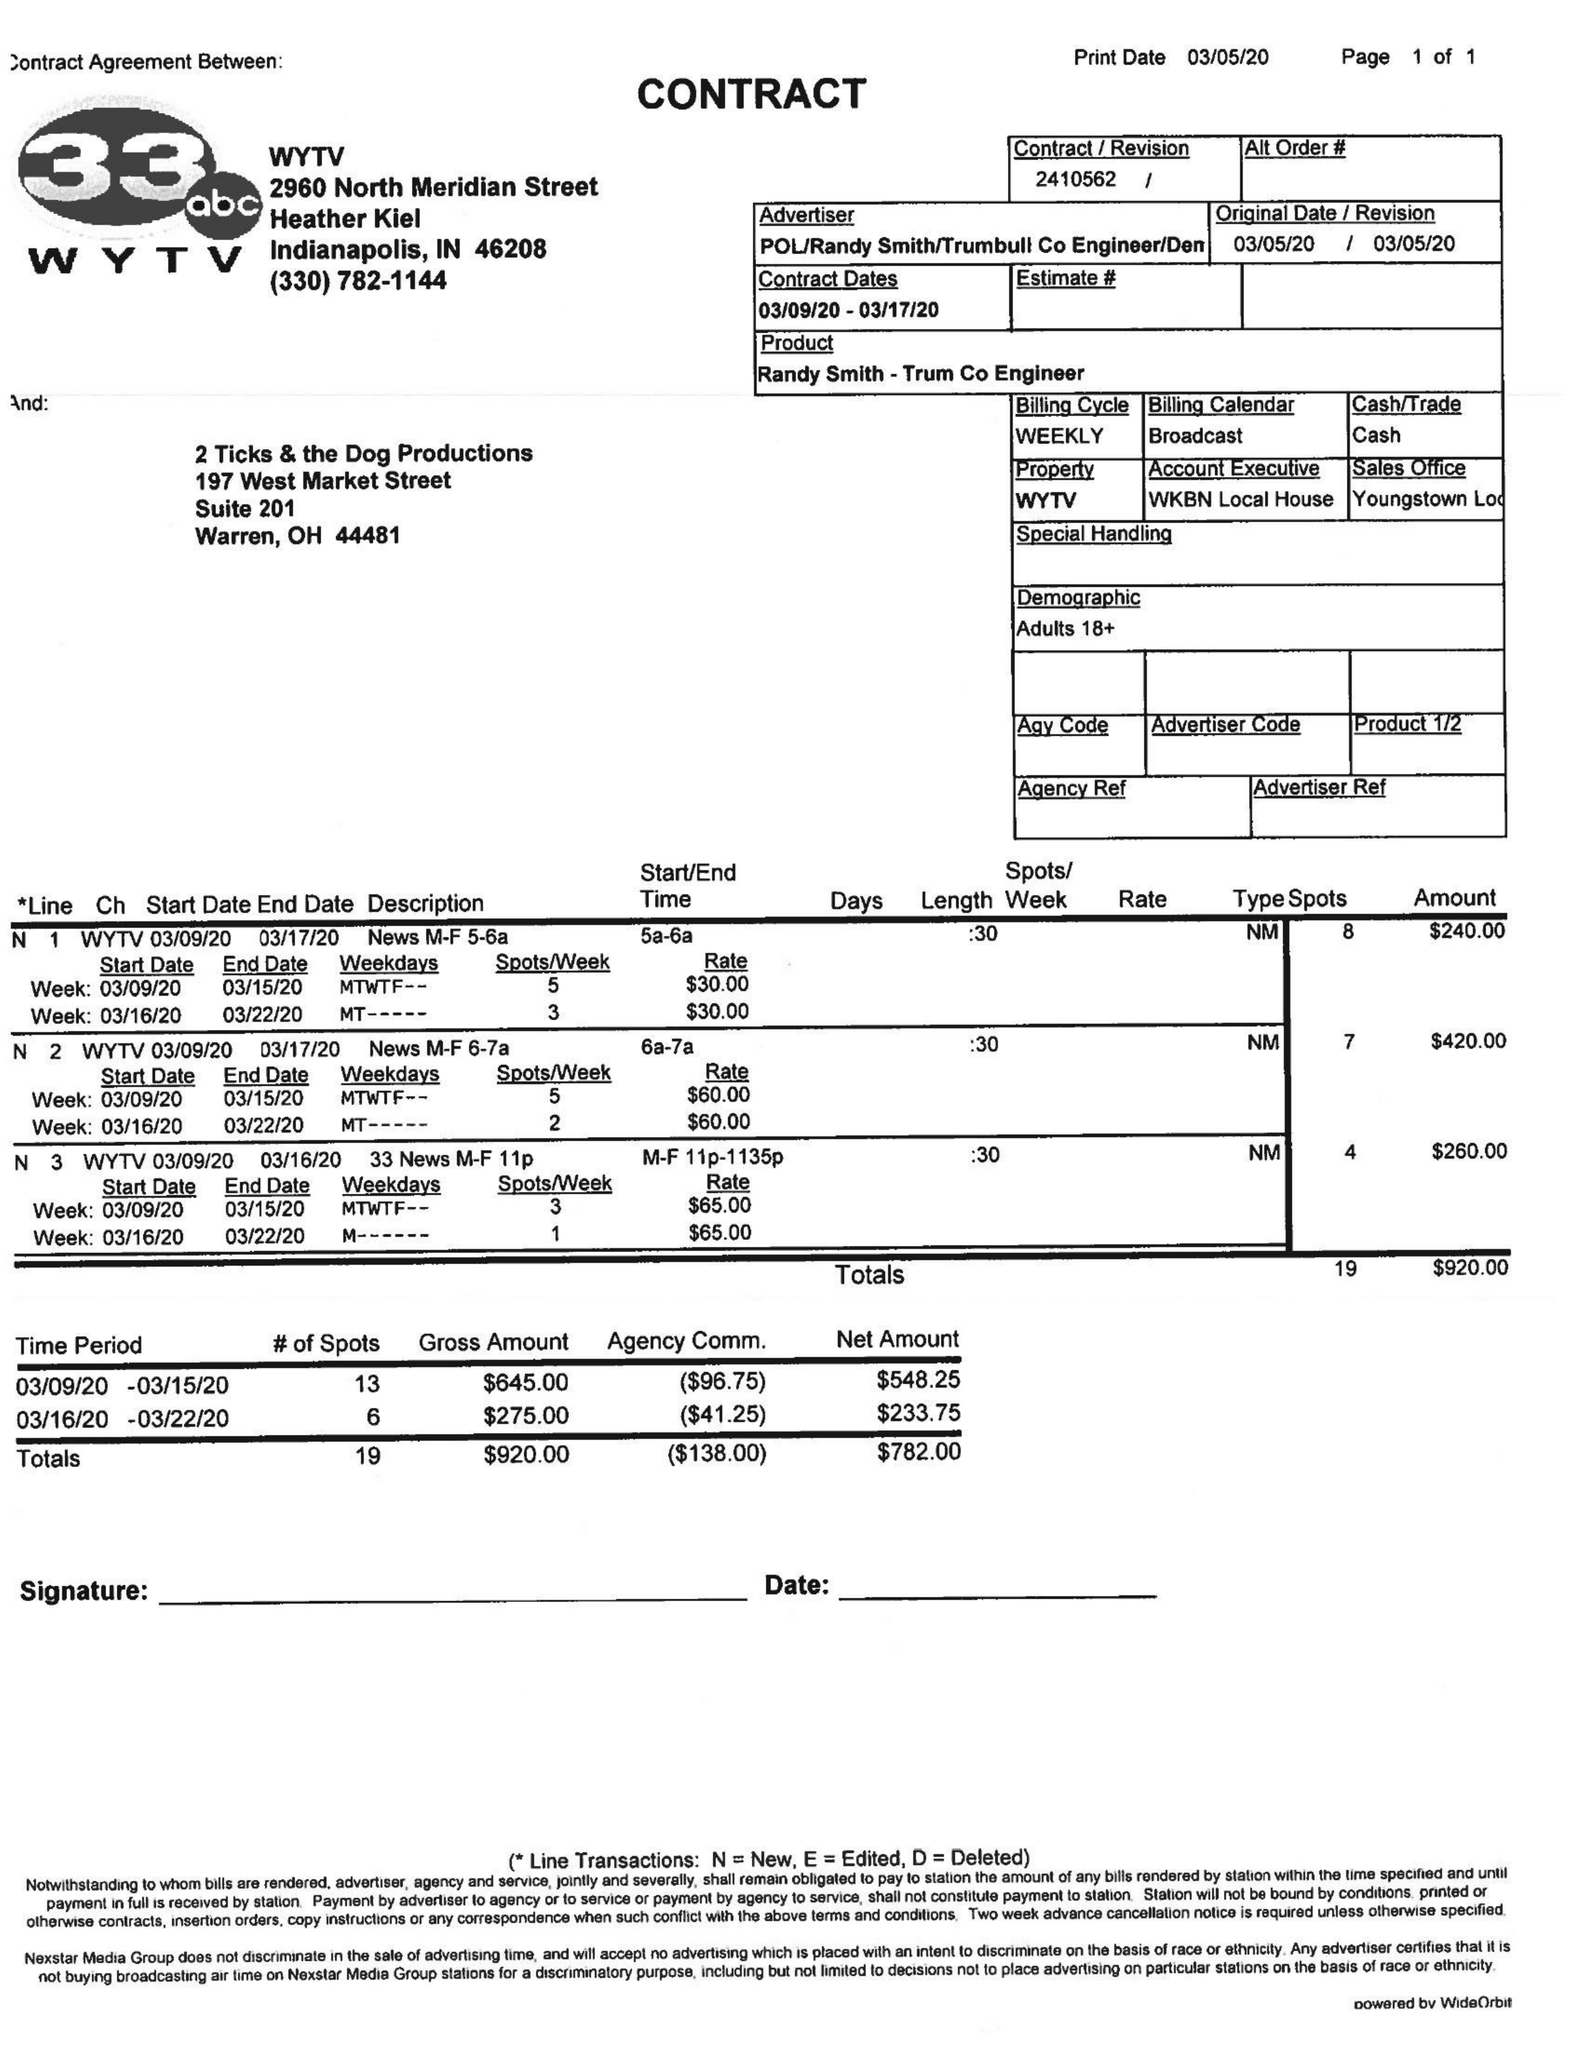What is the value for the contract_num?
Answer the question using a single word or phrase. 2410562 